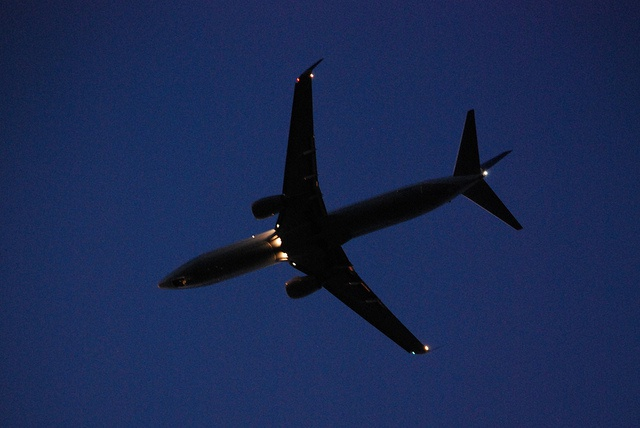Describe the objects in this image and their specific colors. I can see a airplane in black, navy, maroon, and gray tones in this image. 